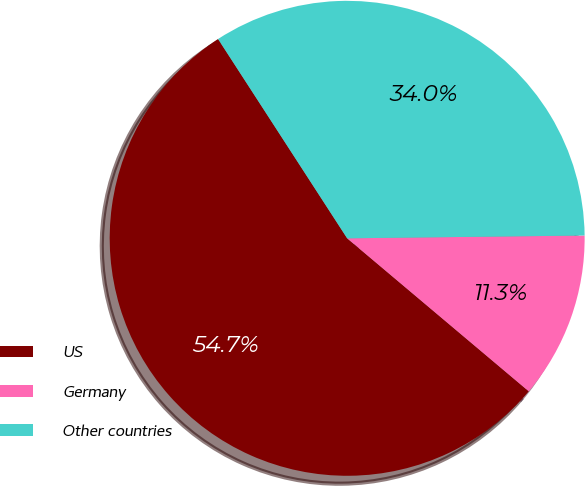<chart> <loc_0><loc_0><loc_500><loc_500><pie_chart><fcel>US<fcel>Germany<fcel>Other countries<nl><fcel>54.71%<fcel>11.33%<fcel>33.96%<nl></chart> 